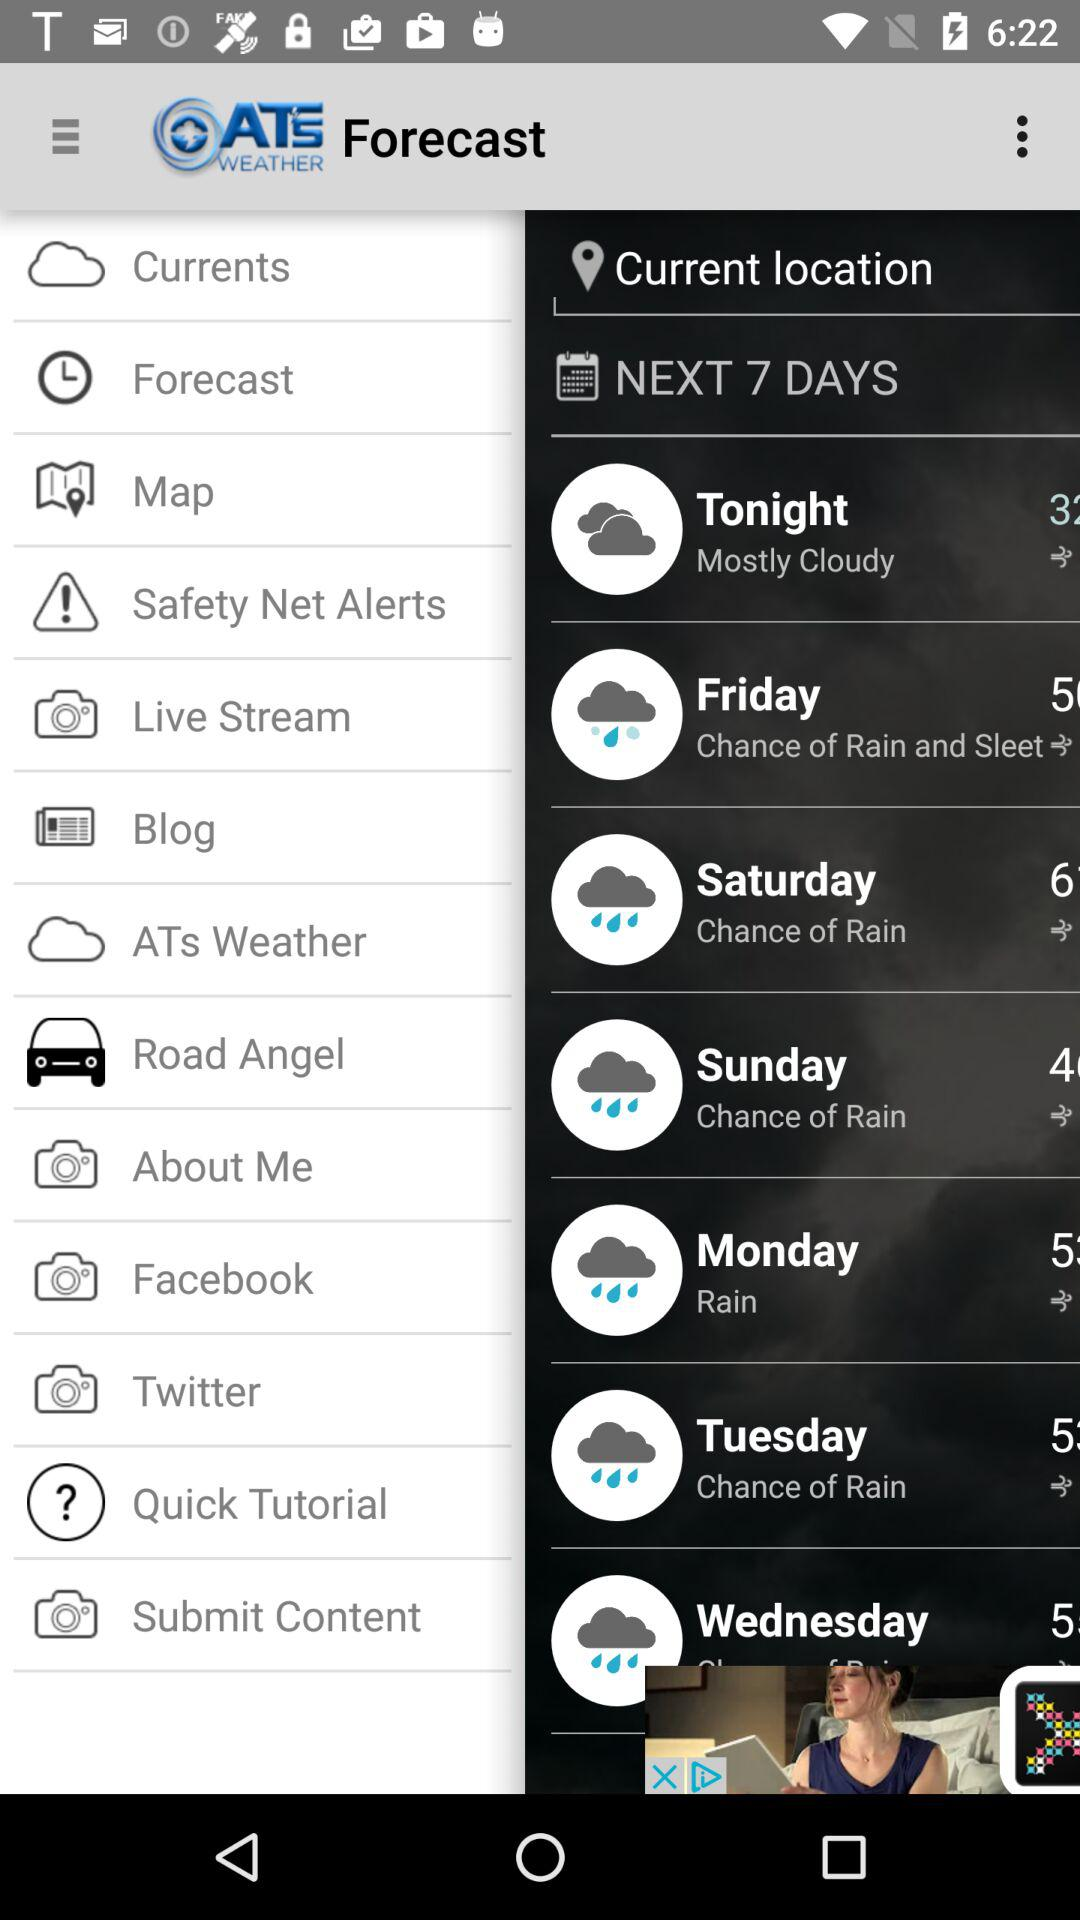What is the temperature on Monday? The temperature on Monday is rainy. 